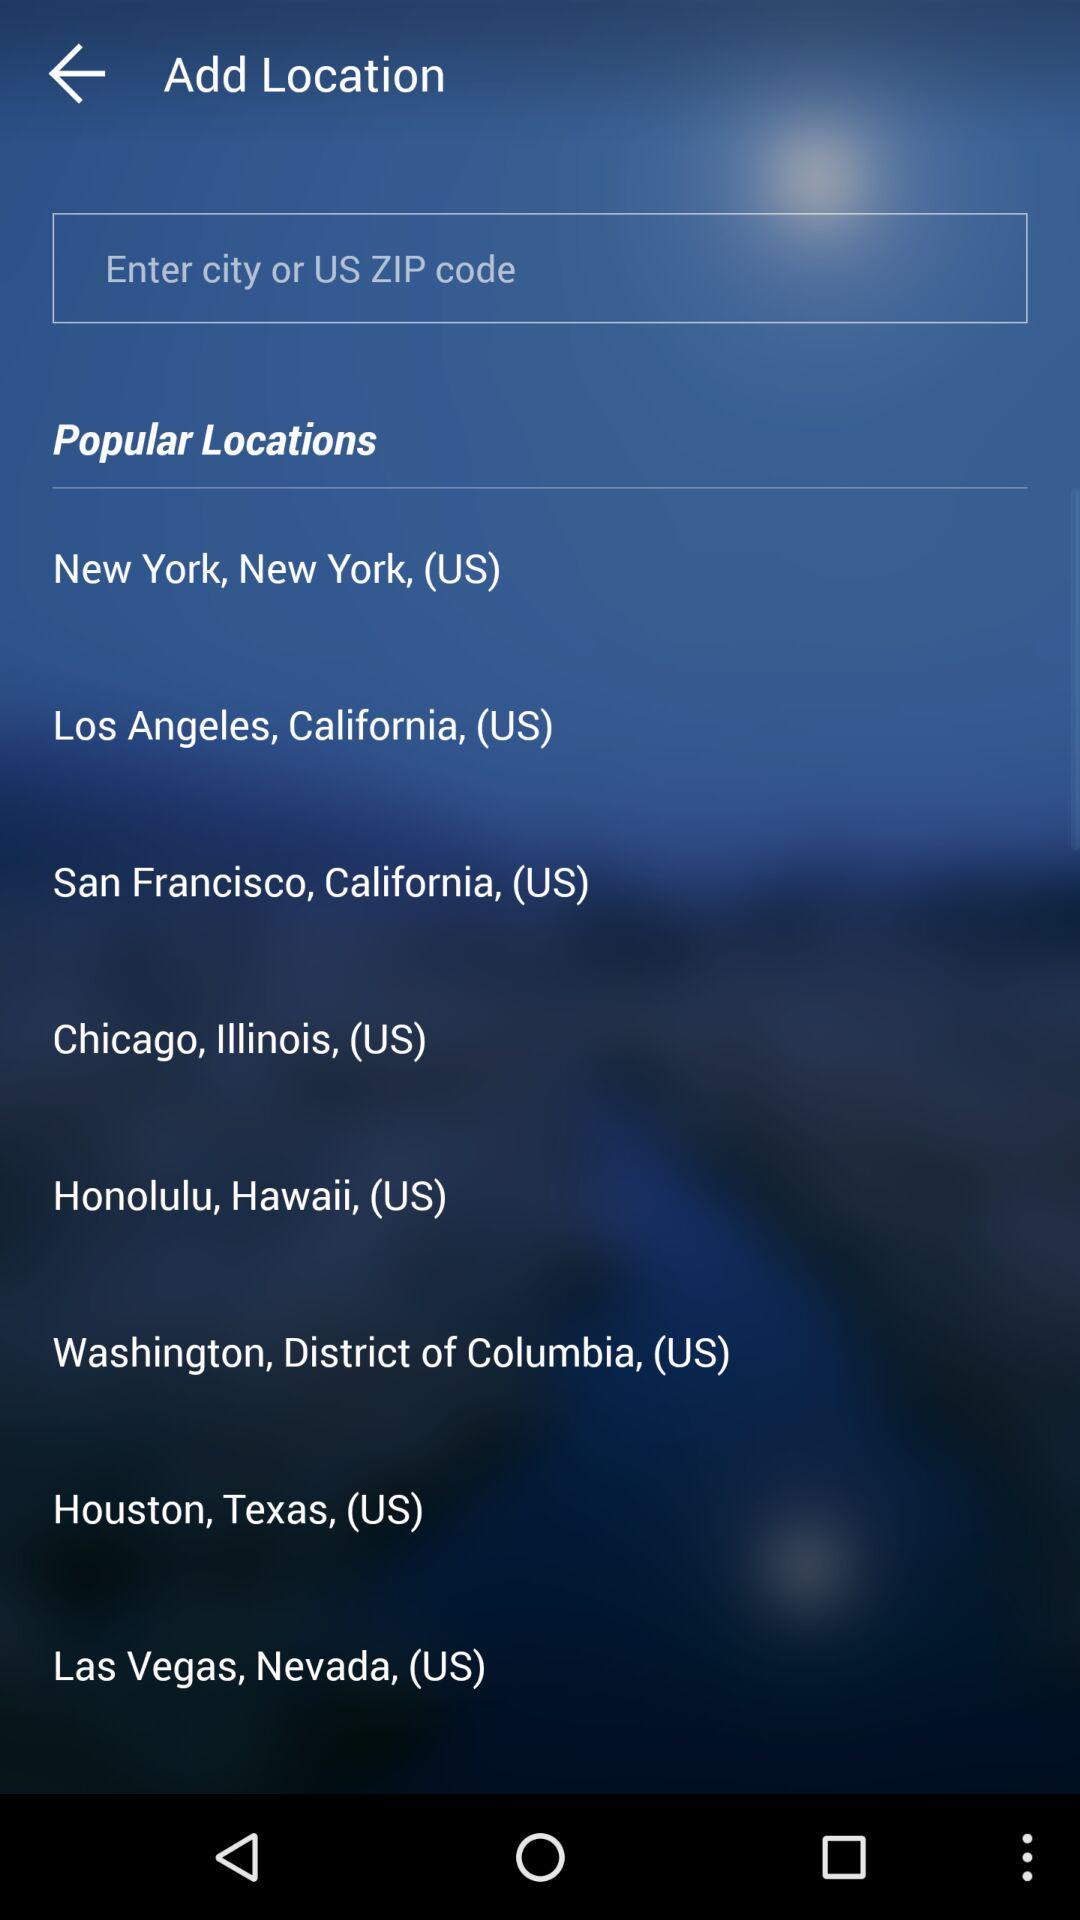How many locations are in the United States?
Answer the question using a single word or phrase. 8 